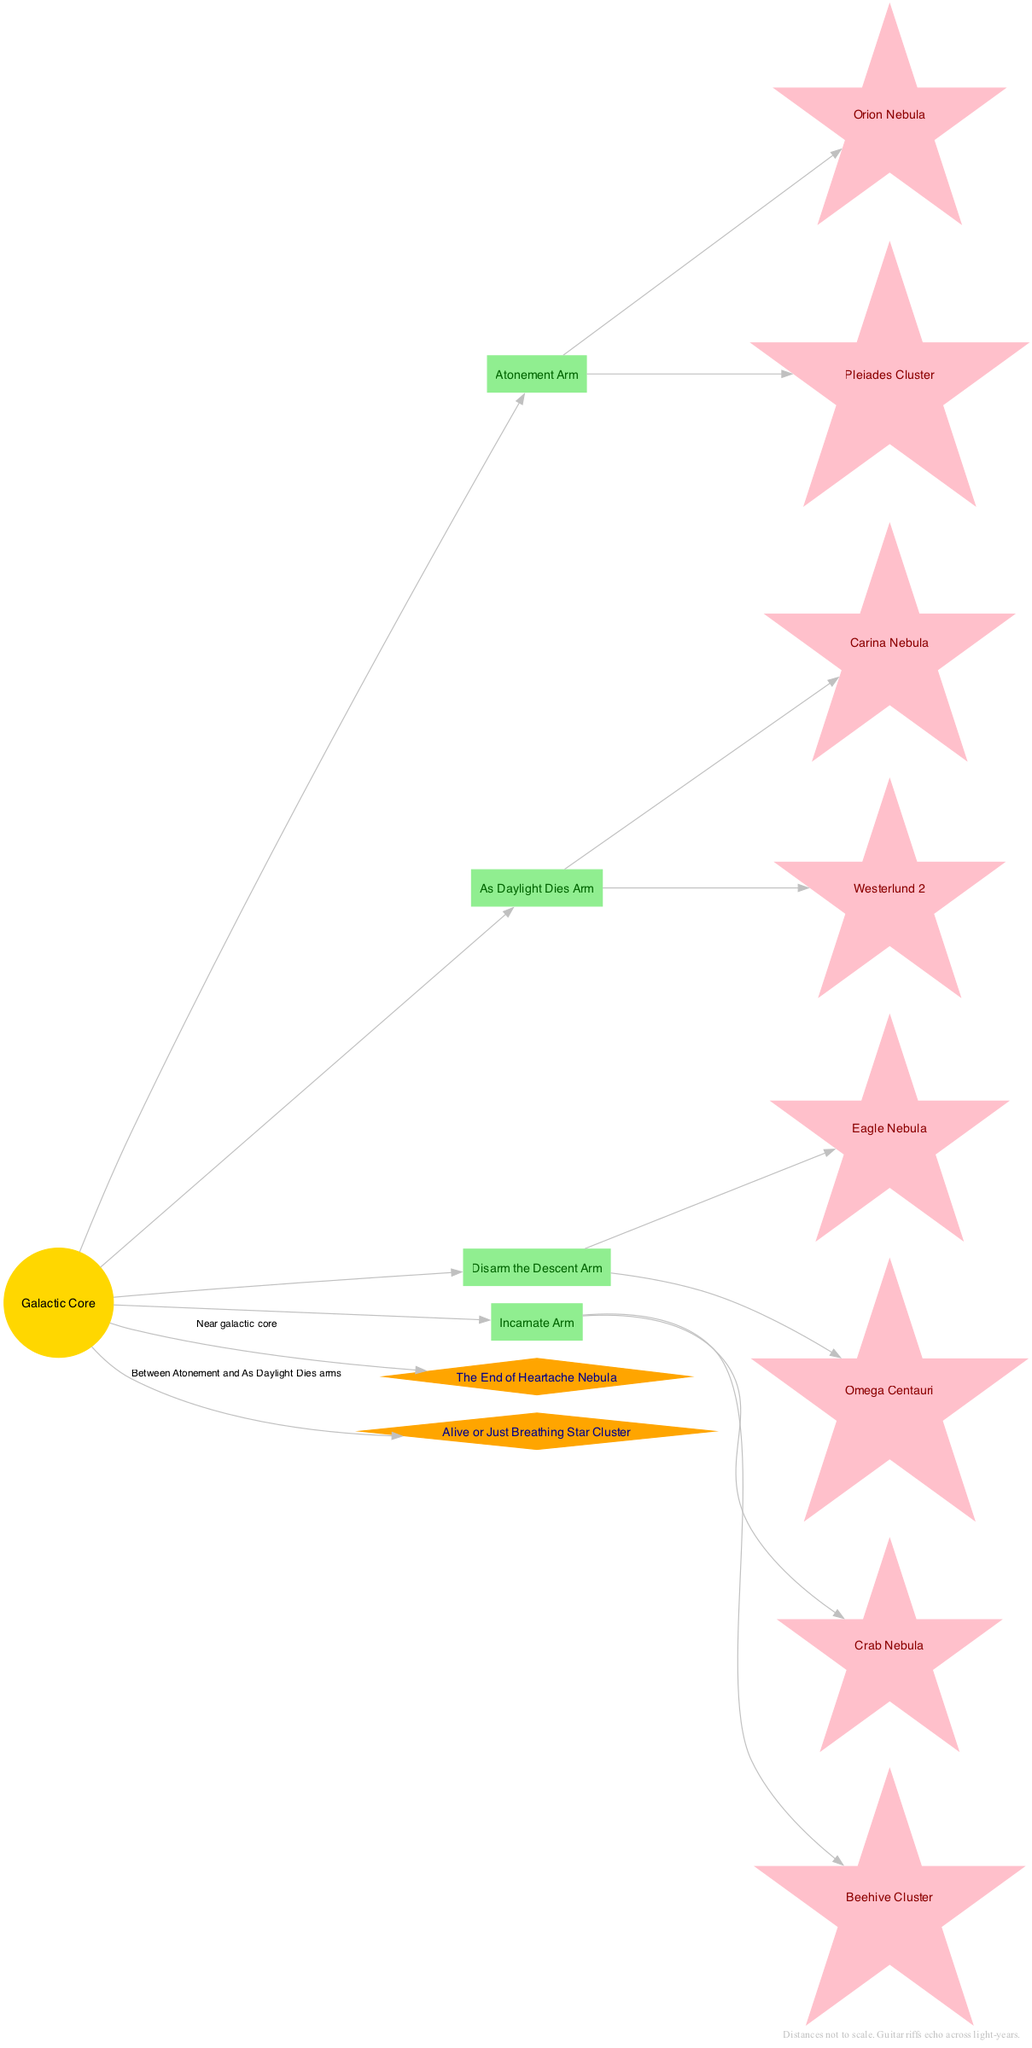What is at the center of the Milky Way diagram? The diagram labels the central feature as the "Galactic Core," indicating that it is the focal point of the structure. This is directly stated in the diagram's legend or node.
Answer: Galactic Core How many arms are represented in the diagram? The diagram features four distinct arms, each labeled after different Killswitch Engage albums. This can be counted by visually identifying the labeled arms connected to the Galactic Core.
Answer: Four Which nebula is located in the Atonement Arm? Within the Atonement Arm, the diagram specifies the "Orion Nebula" as one of its highlighted features. This can be found under the corresponding arm section.
Answer: Orion Nebula What feature is located between the Atonement and As Daylight Dies arms? The diagram notes the "Alive or Just Breathing Star Cluster" as the feature situated between the Atonement and As Daylight Dies arms, confirming its position through the lines connecting it to the Galactic Core.
Answer: Alive or Just Breathing Star Cluster Which arm features the Crab Nebula? The "Incarnate Arm" is identified in the diagram as housing the Crab Nebula among its features, confirming its placement by referencing the distinct arm.
Answer: Incarnate Arm What is the location of The End of Heartache Nebula? The diagram specifies that The End of Heartache Nebula is located "Near galactic core," which can be discerned from the labeled edge connecting it to the core.
Answer: Near galactic core Which features are present in the Disarm the Descent Arm? The Disarm the Descent Arm includes the "Eagle Nebula" and "Omega Centauri" as its notable features. These can be listed by checking the specific elements under that arm in the diagram.
Answer: Eagle Nebula, Omega Centauri How many total features are highlighted around the Galactic Core? The diagram highlights six features around the Galactic Core: four arms with two features each (8 total) and two additional features (1 near the core and 1 between arms), bringing the count to a total of six specific identifiable features.
Answer: Six What is the color of the arms in the diagram? All the arms in the diagram are colored "lightgreen," which can be observed by looking at the sections designated for each arm.
Answer: Lightgreen Which arm contains the Carina Nebula? The diagram shows that the Carina Nebula is part of the "As Daylight Dies Arm." This can be confirmed by associating the feature with the respective arm labeled in the diagram.
Answer: As Daylight Dies Arm 